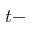<formula> <loc_0><loc_0><loc_500><loc_500>t -</formula> 